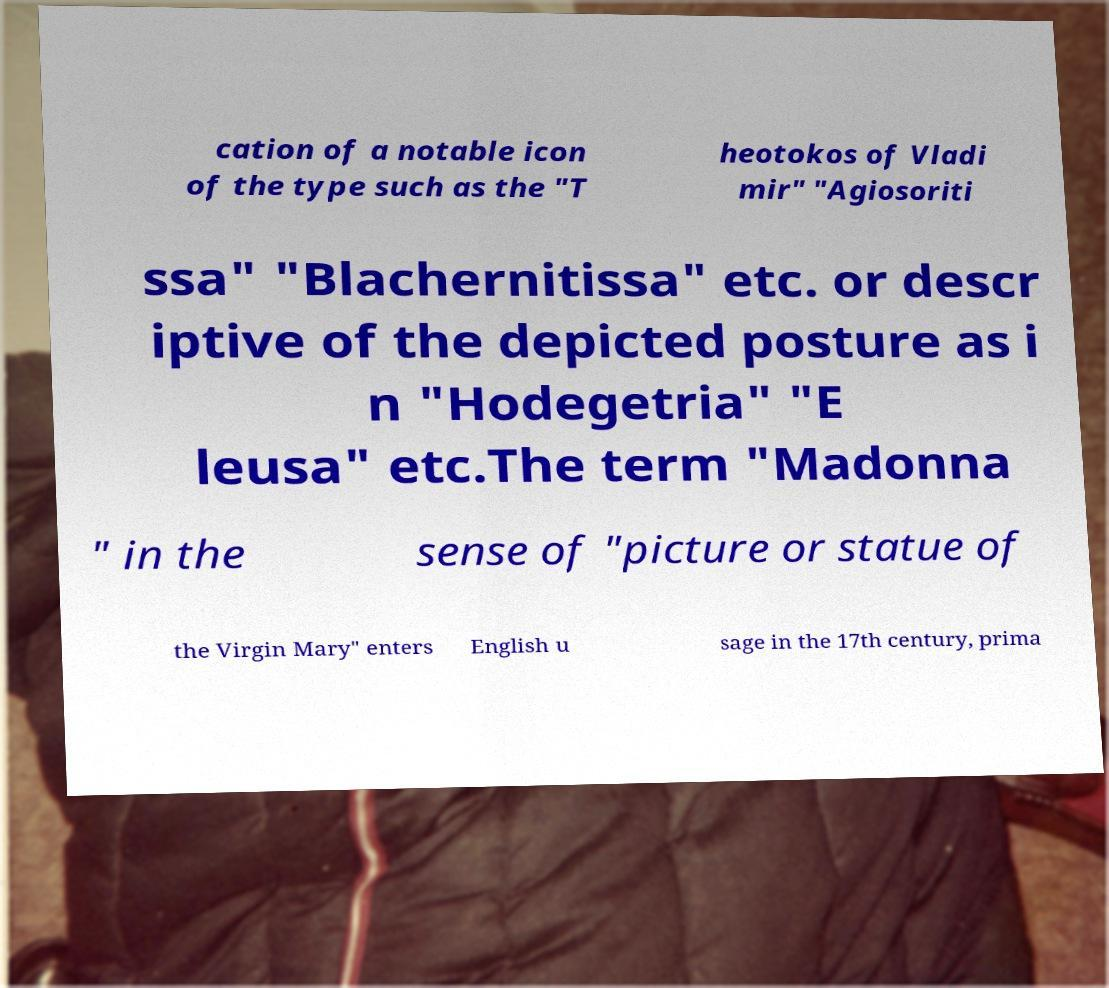Please identify and transcribe the text found in this image. cation of a notable icon of the type such as the "T heotokos of Vladi mir" "Agiosoriti ssa" "Blachernitissa" etc. or descr iptive of the depicted posture as i n "Hodegetria" "E leusa" etc.The term "Madonna " in the sense of "picture or statue of the Virgin Mary" enters English u sage in the 17th century, prima 